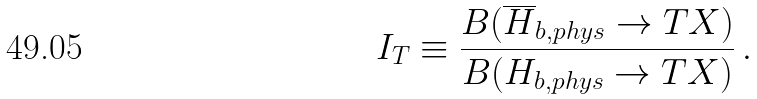<formula> <loc_0><loc_0><loc_500><loc_500>I _ { T } \equiv \frac { B ( \overline { H } _ { b , p h y s } \to T X ) } { B ( H _ { b , p h y s } \to T X ) } \, .</formula> 